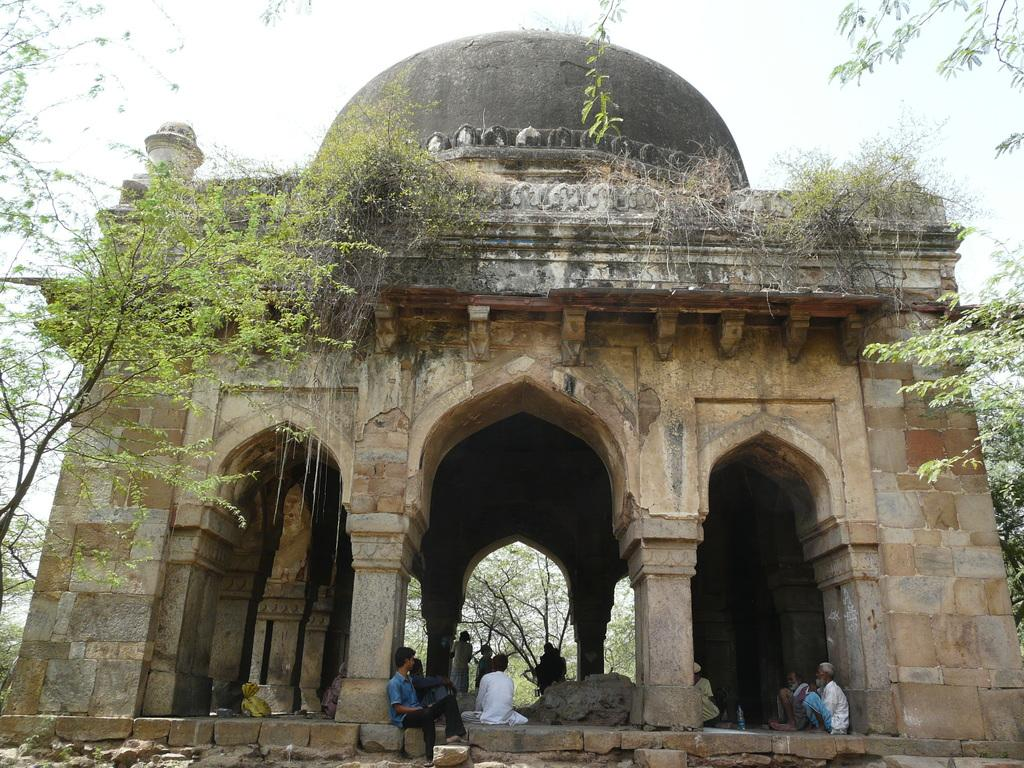What type of structure is present in the image? There is a fort in the image. Are there any people inside the fort? Yes, there are people inside the fort. What can be seen in the background of the image? Trees and the sky are visible in the image. What type of silk is being used to kick the ball in the image? There is no ball or silk present in the image; it features a fort with people inside. 